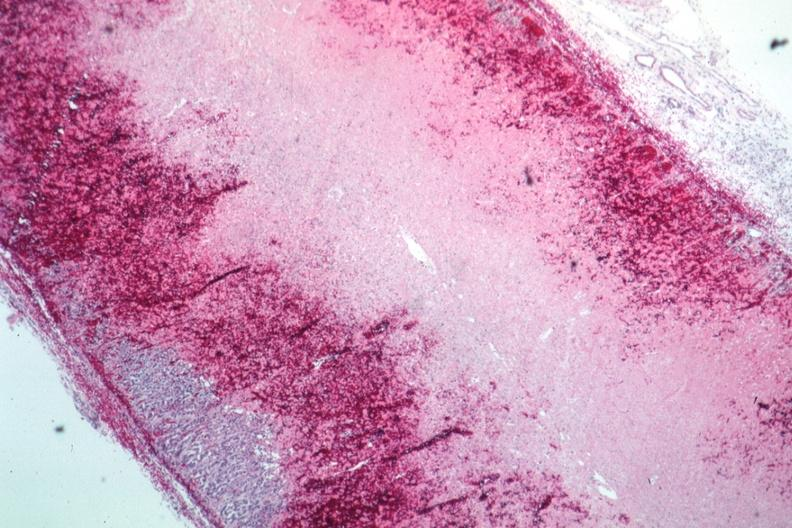s hemorrhage newborn present?
Answer the question using a single word or phrase. Yes 